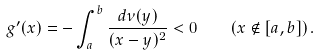<formula> <loc_0><loc_0><loc_500><loc_500>g ^ { \prime } ( x ) = - \int _ { a } ^ { b } \frac { d \nu ( y ) } { ( x - y ) ^ { 2 } } < 0 \quad ( x \notin [ a , b ] ) \, .</formula> 